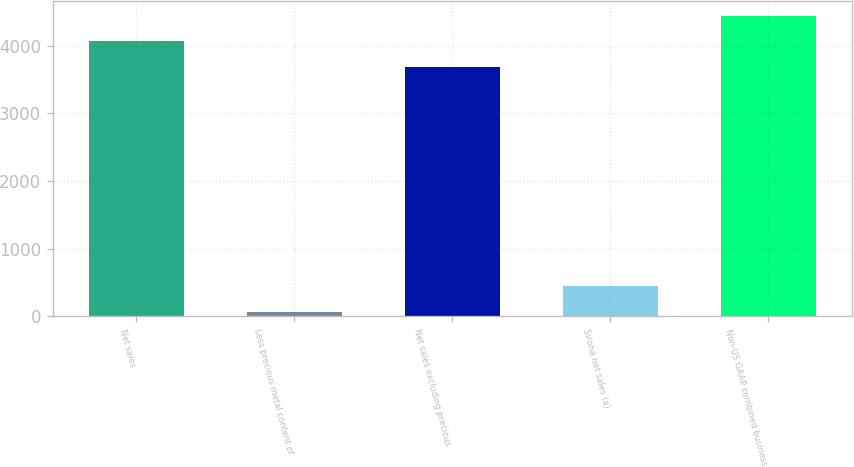Convert chart. <chart><loc_0><loc_0><loc_500><loc_500><bar_chart><fcel>Net sales<fcel>Less precious metal content of<fcel>Net sales excluding precious<fcel>Sirona net sales (a)<fcel>Non-US GAAP combined business<nl><fcel>4060.04<fcel>64.3<fcel>3681<fcel>443.34<fcel>4439.08<nl></chart> 